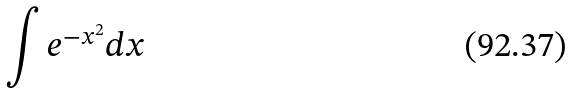<formula> <loc_0><loc_0><loc_500><loc_500>\int e ^ { - x ^ { 2 } } d x</formula> 